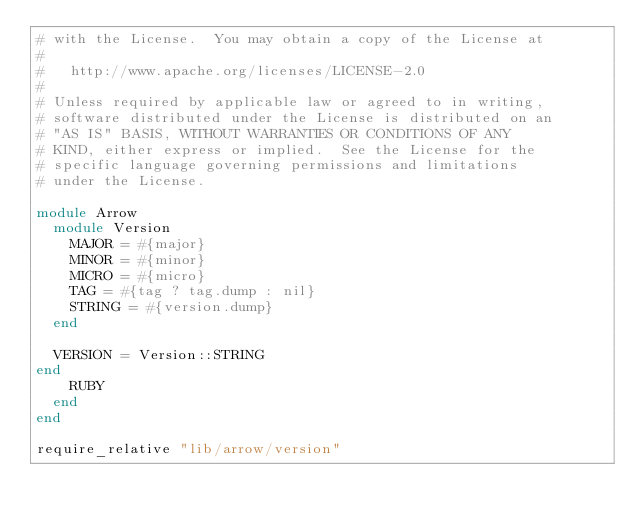<code> <loc_0><loc_0><loc_500><loc_500><_Ruby_># with the License.  You may obtain a copy of the License at
#
#   http://www.apache.org/licenses/LICENSE-2.0
#
# Unless required by applicable law or agreed to in writing,
# software distributed under the License is distributed on an
# "AS IS" BASIS, WITHOUT WARRANTIES OR CONDITIONS OF ANY
# KIND, either express or implied.  See the License for the
# specific language governing permissions and limitations
# under the License.

module Arrow
  module Version
    MAJOR = #{major}
    MINOR = #{minor}
    MICRO = #{micro}
    TAG = #{tag ? tag.dump : nil}
    STRING = #{version.dump}
  end

  VERSION = Version::STRING
end
    RUBY
  end
end

require_relative "lib/arrow/version"
</code> 